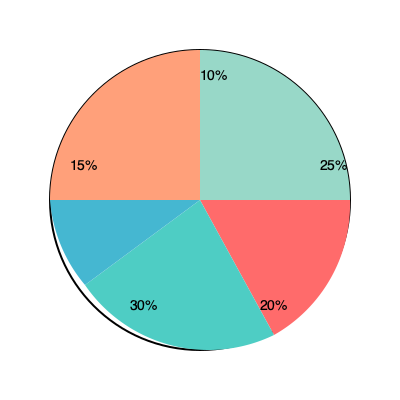As a mid-level manager, you're analyzing the market share of your company and its competitors. The pie chart above represents the current market distribution. If your company's market share is 20% and you're aiming to overtake the market leader, what percentage point increase in market share do you need to achieve? To solve this problem, we need to follow these steps:

1. Identify the company's current market share: 20%

2. Identify the market leader's share:
   The largest slice in the pie chart is 30%

3. Calculate the difference between the market leader and the company:
   $30\% - 20\% = 10\%$

4. To overtake the market leader, the company needs to increase its market share by slightly more than this difference.

Therefore, the company needs to increase its market share by more than 10 percentage points to overtake the current market leader.

This analysis is crucial for setting strategic goals and understanding the competitive landscape. As a mid-level manager with strong networking skills, you can use this information to develop strategies for market expansion and to communicate growth targets to your team and stakeholders.
Answer: 10 percentage points 